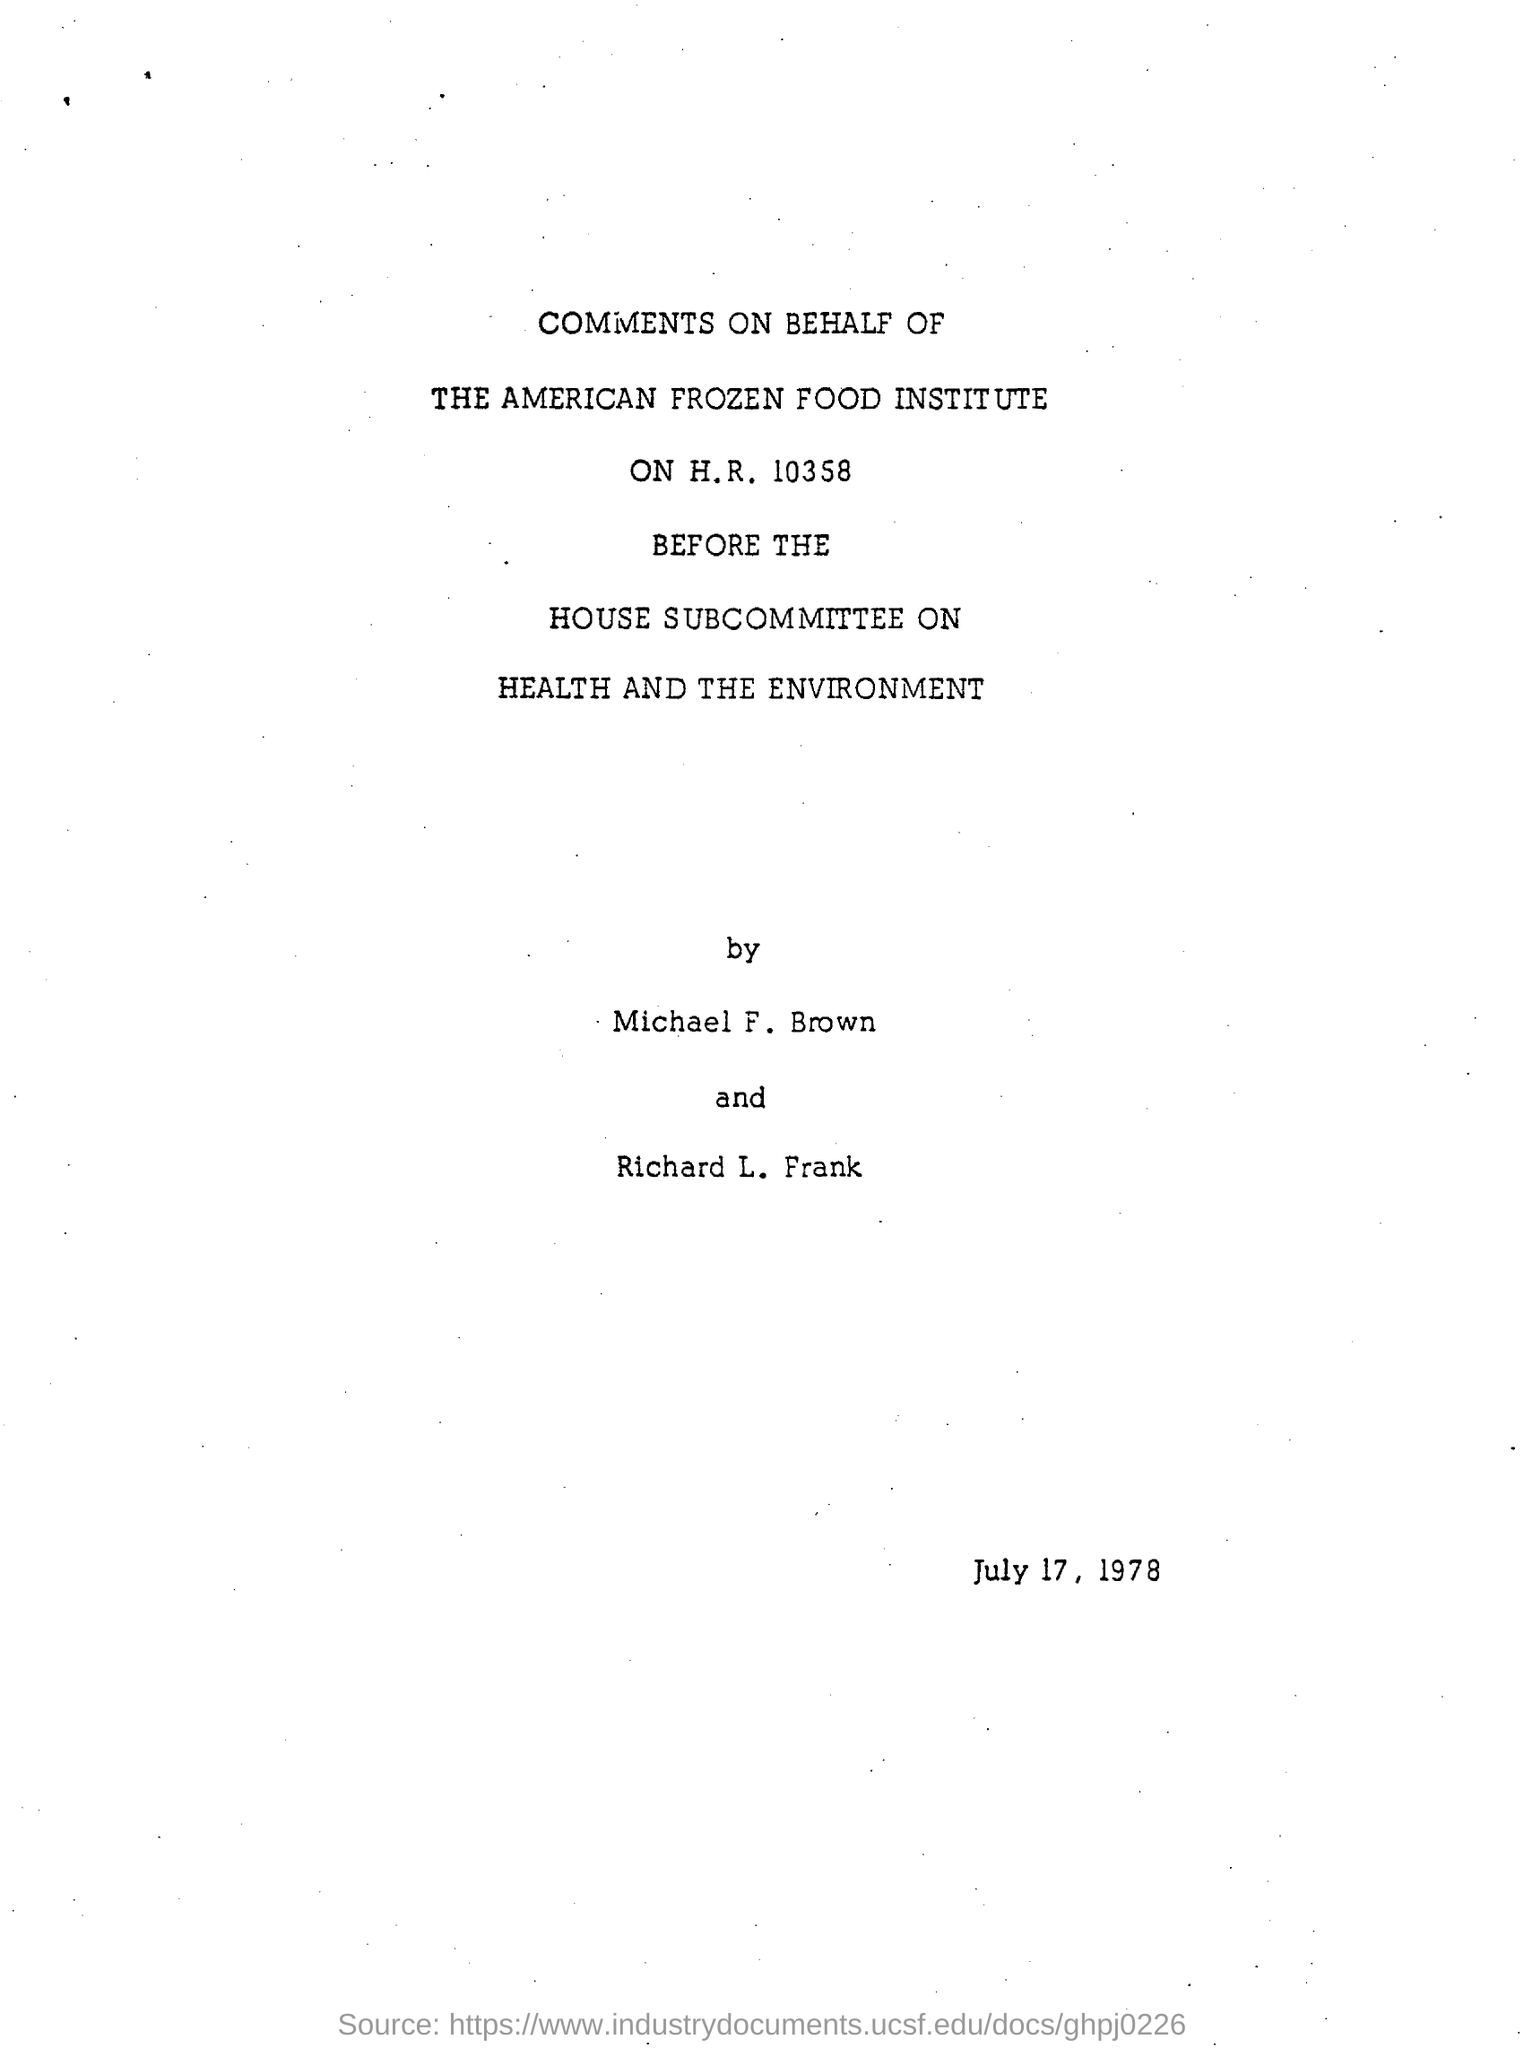Who has written the comments?
Your answer should be compact. Michael f. brown and richard l. frank. What is the name of the food institute
Give a very brief answer. The american frozen food institute. What is the date mentioned in the document?
Your answer should be very brief. July 17 , 1978. 